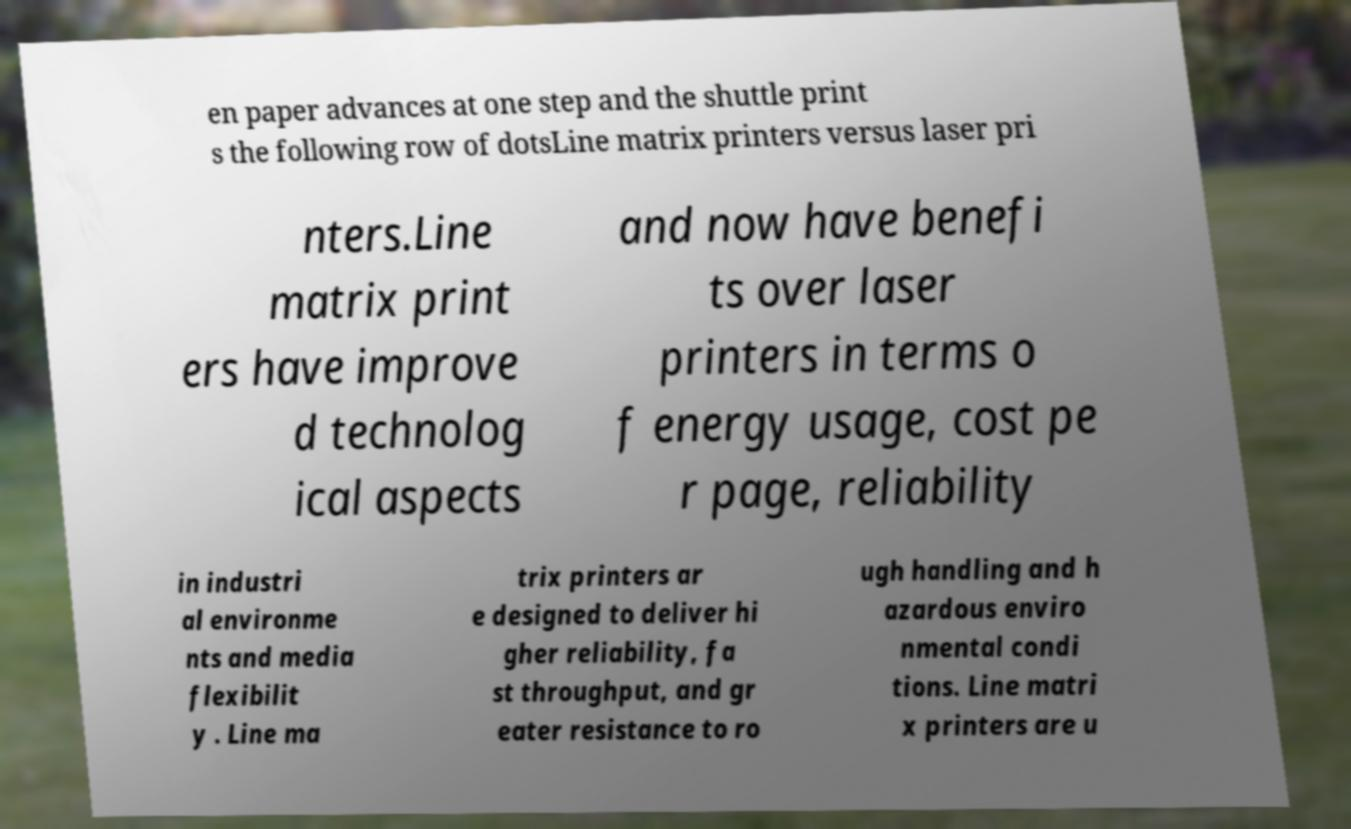Could you extract and type out the text from this image? en paper advances at one step and the shuttle print s the following row of dotsLine matrix printers versus laser pri nters.Line matrix print ers have improve d technolog ical aspects and now have benefi ts over laser printers in terms o f energy usage, cost pe r page, reliability in industri al environme nts and media flexibilit y . Line ma trix printers ar e designed to deliver hi gher reliability, fa st throughput, and gr eater resistance to ro ugh handling and h azardous enviro nmental condi tions. Line matri x printers are u 